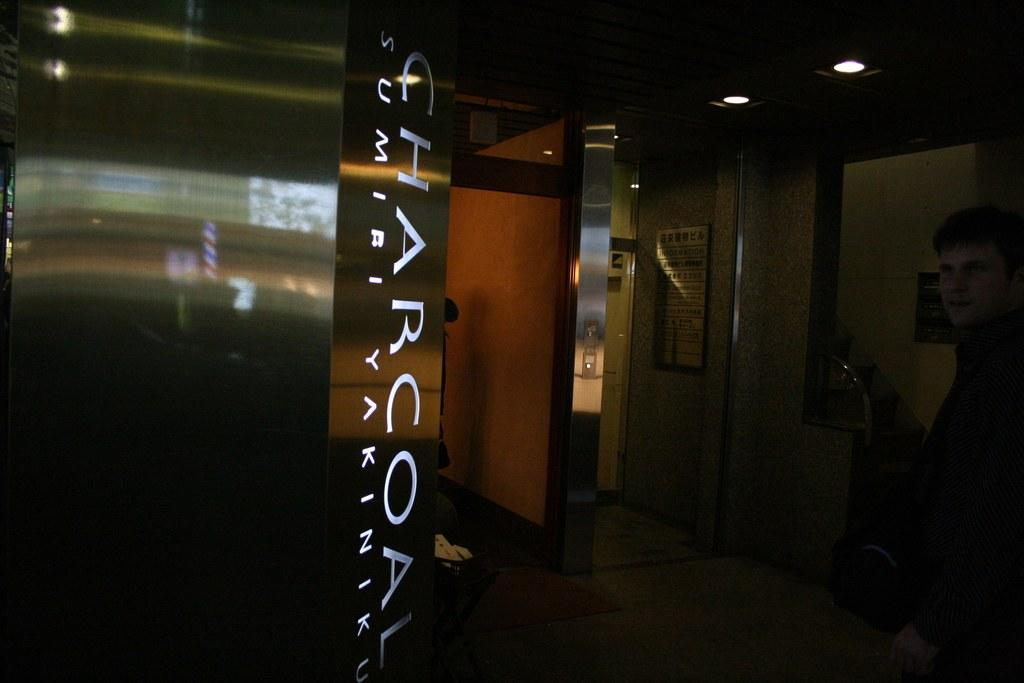Who or what is present in the image? There is a person in the image. What can be seen in the background of the image? There are boards, lights, and a wall in the background of the image. What is the surface that the person is standing on? There is a floor at the bottom of the image. What type of system is the ghost using to smash the boards in the image? There is no ghost or system present in the image, and the boards are not being smashed. 